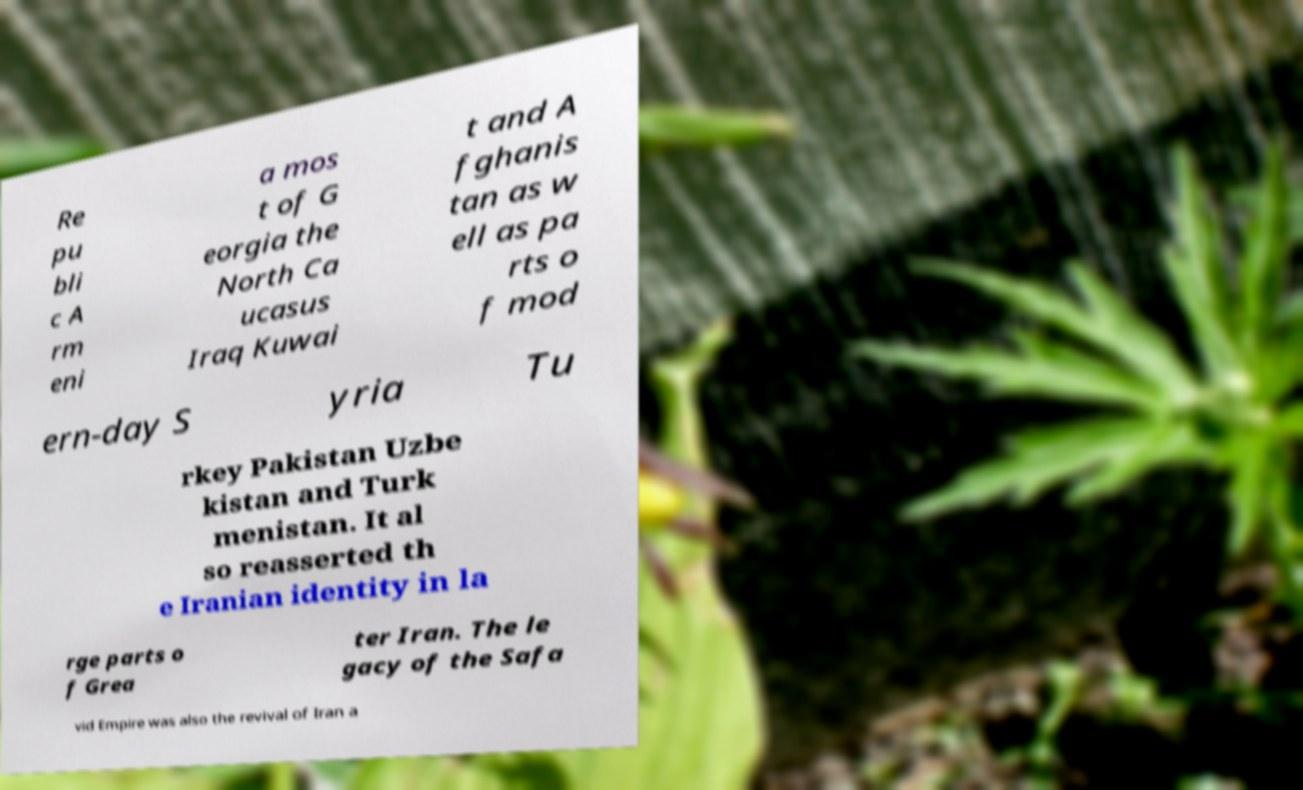What messages or text are displayed in this image? I need them in a readable, typed format. Re pu bli c A rm eni a mos t of G eorgia the North Ca ucasus Iraq Kuwai t and A fghanis tan as w ell as pa rts o f mod ern-day S yria Tu rkey Pakistan Uzbe kistan and Turk menistan. It al so reasserted th e Iranian identity in la rge parts o f Grea ter Iran. The le gacy of the Safa vid Empire was also the revival of Iran a 